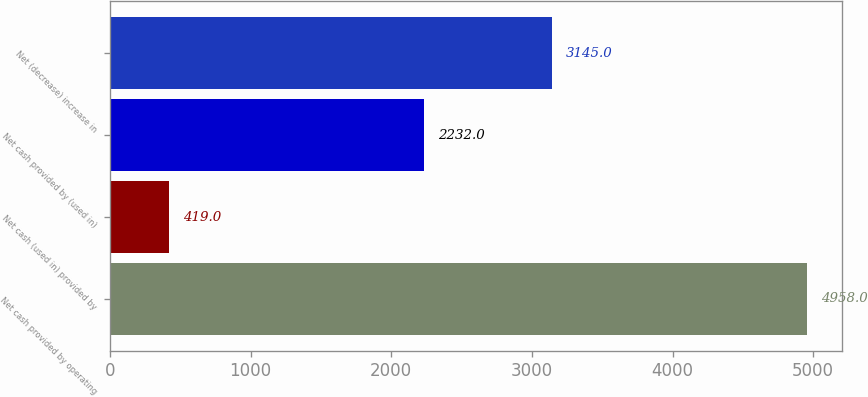<chart> <loc_0><loc_0><loc_500><loc_500><bar_chart><fcel>Net cash provided by operating<fcel>Net cash (used in) provided by<fcel>Net cash provided by (used in)<fcel>Net (decrease) increase in<nl><fcel>4958<fcel>419<fcel>2232<fcel>3145<nl></chart> 